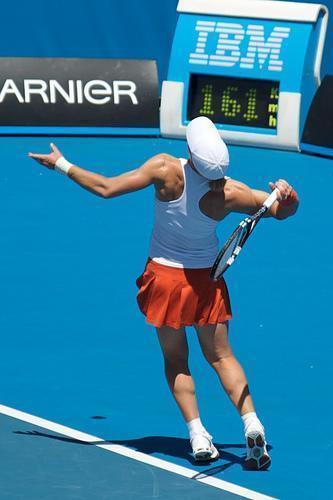What is the person doing?
Answer the question by selecting the correct answer among the 4 following choices.
Options: Returning, star gazing, sun spotting, serving. Serving. 